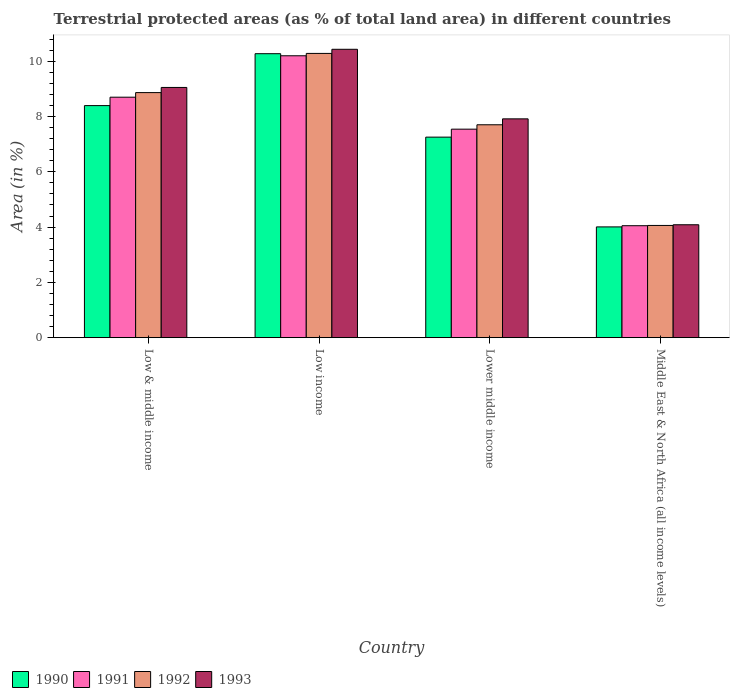Are the number of bars on each tick of the X-axis equal?
Offer a terse response. Yes. In how many cases, is the number of bars for a given country not equal to the number of legend labels?
Give a very brief answer. 0. What is the percentage of terrestrial protected land in 1993 in Lower middle income?
Ensure brevity in your answer.  7.92. Across all countries, what is the maximum percentage of terrestrial protected land in 1993?
Offer a terse response. 10.43. Across all countries, what is the minimum percentage of terrestrial protected land in 1991?
Provide a succinct answer. 4.05. In which country was the percentage of terrestrial protected land in 1992 maximum?
Offer a very short reply. Low income. In which country was the percentage of terrestrial protected land in 1991 minimum?
Make the answer very short. Middle East & North Africa (all income levels). What is the total percentage of terrestrial protected land in 1991 in the graph?
Ensure brevity in your answer.  30.49. What is the difference between the percentage of terrestrial protected land in 1992 in Low & middle income and that in Middle East & North Africa (all income levels)?
Make the answer very short. 4.81. What is the difference between the percentage of terrestrial protected land in 1991 in Low & middle income and the percentage of terrestrial protected land in 1993 in Lower middle income?
Your answer should be compact. 0.78. What is the average percentage of terrestrial protected land in 1993 per country?
Provide a short and direct response. 7.87. What is the difference between the percentage of terrestrial protected land of/in 1993 and percentage of terrestrial protected land of/in 1992 in Low income?
Offer a terse response. 0.15. What is the ratio of the percentage of terrestrial protected land in 1992 in Low income to that in Lower middle income?
Keep it short and to the point. 1.34. Is the percentage of terrestrial protected land in 1991 in Lower middle income less than that in Middle East & North Africa (all income levels)?
Your answer should be very brief. No. What is the difference between the highest and the second highest percentage of terrestrial protected land in 1992?
Give a very brief answer. -1.42. What is the difference between the highest and the lowest percentage of terrestrial protected land in 1993?
Your answer should be compact. 6.35. Is the sum of the percentage of terrestrial protected land in 1991 in Lower middle income and Middle East & North Africa (all income levels) greater than the maximum percentage of terrestrial protected land in 1993 across all countries?
Your answer should be very brief. Yes. What does the 3rd bar from the right in Lower middle income represents?
Your response must be concise. 1991. Is it the case that in every country, the sum of the percentage of terrestrial protected land in 1992 and percentage of terrestrial protected land in 1991 is greater than the percentage of terrestrial protected land in 1993?
Provide a short and direct response. Yes. How many bars are there?
Your answer should be very brief. 16. Are all the bars in the graph horizontal?
Offer a terse response. No. Are the values on the major ticks of Y-axis written in scientific E-notation?
Ensure brevity in your answer.  No. Does the graph contain grids?
Give a very brief answer. No. Where does the legend appear in the graph?
Offer a terse response. Bottom left. How many legend labels are there?
Your answer should be very brief. 4. How are the legend labels stacked?
Offer a very short reply. Horizontal. What is the title of the graph?
Ensure brevity in your answer.  Terrestrial protected areas (as % of total land area) in different countries. What is the label or title of the Y-axis?
Give a very brief answer. Area (in %). What is the Area (in %) in 1990 in Low & middle income?
Your answer should be very brief. 8.4. What is the Area (in %) of 1991 in Low & middle income?
Provide a short and direct response. 8.7. What is the Area (in %) of 1992 in Low & middle income?
Your answer should be compact. 8.87. What is the Area (in %) in 1993 in Low & middle income?
Give a very brief answer. 9.05. What is the Area (in %) in 1990 in Low income?
Your response must be concise. 10.27. What is the Area (in %) in 1991 in Low income?
Your response must be concise. 10.2. What is the Area (in %) in 1992 in Low income?
Your answer should be compact. 10.28. What is the Area (in %) of 1993 in Low income?
Your answer should be very brief. 10.43. What is the Area (in %) in 1990 in Lower middle income?
Ensure brevity in your answer.  7.26. What is the Area (in %) of 1991 in Lower middle income?
Offer a very short reply. 7.54. What is the Area (in %) of 1992 in Lower middle income?
Your answer should be compact. 7.7. What is the Area (in %) of 1993 in Lower middle income?
Offer a terse response. 7.92. What is the Area (in %) in 1990 in Middle East & North Africa (all income levels)?
Provide a short and direct response. 4.01. What is the Area (in %) of 1991 in Middle East & North Africa (all income levels)?
Your answer should be very brief. 4.05. What is the Area (in %) of 1992 in Middle East & North Africa (all income levels)?
Provide a short and direct response. 4.06. What is the Area (in %) in 1993 in Middle East & North Africa (all income levels)?
Your answer should be compact. 4.08. Across all countries, what is the maximum Area (in %) in 1990?
Your answer should be compact. 10.27. Across all countries, what is the maximum Area (in %) of 1991?
Provide a short and direct response. 10.2. Across all countries, what is the maximum Area (in %) of 1992?
Your answer should be very brief. 10.28. Across all countries, what is the maximum Area (in %) of 1993?
Offer a terse response. 10.43. Across all countries, what is the minimum Area (in %) in 1990?
Ensure brevity in your answer.  4.01. Across all countries, what is the minimum Area (in %) in 1991?
Offer a very short reply. 4.05. Across all countries, what is the minimum Area (in %) of 1992?
Your answer should be compact. 4.06. Across all countries, what is the minimum Area (in %) in 1993?
Your answer should be very brief. 4.08. What is the total Area (in %) in 1990 in the graph?
Your answer should be compact. 29.93. What is the total Area (in %) in 1991 in the graph?
Your answer should be very brief. 30.49. What is the total Area (in %) in 1992 in the graph?
Ensure brevity in your answer.  30.91. What is the total Area (in %) of 1993 in the graph?
Make the answer very short. 31.49. What is the difference between the Area (in %) of 1990 in Low & middle income and that in Low income?
Your answer should be very brief. -1.88. What is the difference between the Area (in %) in 1991 in Low & middle income and that in Low income?
Offer a terse response. -1.5. What is the difference between the Area (in %) in 1992 in Low & middle income and that in Low income?
Offer a very short reply. -1.42. What is the difference between the Area (in %) in 1993 in Low & middle income and that in Low income?
Your answer should be compact. -1.38. What is the difference between the Area (in %) of 1990 in Low & middle income and that in Lower middle income?
Your answer should be very brief. 1.14. What is the difference between the Area (in %) in 1991 in Low & middle income and that in Lower middle income?
Keep it short and to the point. 1.16. What is the difference between the Area (in %) of 1992 in Low & middle income and that in Lower middle income?
Give a very brief answer. 1.16. What is the difference between the Area (in %) in 1993 in Low & middle income and that in Lower middle income?
Provide a succinct answer. 1.14. What is the difference between the Area (in %) in 1990 in Low & middle income and that in Middle East & North Africa (all income levels)?
Ensure brevity in your answer.  4.39. What is the difference between the Area (in %) of 1991 in Low & middle income and that in Middle East & North Africa (all income levels)?
Your answer should be compact. 4.65. What is the difference between the Area (in %) in 1992 in Low & middle income and that in Middle East & North Africa (all income levels)?
Offer a very short reply. 4.81. What is the difference between the Area (in %) of 1993 in Low & middle income and that in Middle East & North Africa (all income levels)?
Ensure brevity in your answer.  4.97. What is the difference between the Area (in %) of 1990 in Low income and that in Lower middle income?
Your answer should be very brief. 3.02. What is the difference between the Area (in %) in 1991 in Low income and that in Lower middle income?
Give a very brief answer. 2.65. What is the difference between the Area (in %) in 1992 in Low income and that in Lower middle income?
Give a very brief answer. 2.58. What is the difference between the Area (in %) in 1993 in Low income and that in Lower middle income?
Offer a very short reply. 2.52. What is the difference between the Area (in %) of 1990 in Low income and that in Middle East & North Africa (all income levels)?
Make the answer very short. 6.27. What is the difference between the Area (in %) in 1991 in Low income and that in Middle East & North Africa (all income levels)?
Ensure brevity in your answer.  6.15. What is the difference between the Area (in %) in 1992 in Low income and that in Middle East & North Africa (all income levels)?
Ensure brevity in your answer.  6.22. What is the difference between the Area (in %) of 1993 in Low income and that in Middle East & North Africa (all income levels)?
Make the answer very short. 6.35. What is the difference between the Area (in %) of 1990 in Lower middle income and that in Middle East & North Africa (all income levels)?
Offer a terse response. 3.25. What is the difference between the Area (in %) in 1991 in Lower middle income and that in Middle East & North Africa (all income levels)?
Give a very brief answer. 3.49. What is the difference between the Area (in %) of 1992 in Lower middle income and that in Middle East & North Africa (all income levels)?
Provide a succinct answer. 3.64. What is the difference between the Area (in %) of 1993 in Lower middle income and that in Middle East & North Africa (all income levels)?
Ensure brevity in your answer.  3.83. What is the difference between the Area (in %) of 1990 in Low & middle income and the Area (in %) of 1991 in Low income?
Keep it short and to the point. -1.8. What is the difference between the Area (in %) in 1990 in Low & middle income and the Area (in %) in 1992 in Low income?
Provide a succinct answer. -1.89. What is the difference between the Area (in %) in 1990 in Low & middle income and the Area (in %) in 1993 in Low income?
Offer a very short reply. -2.04. What is the difference between the Area (in %) of 1991 in Low & middle income and the Area (in %) of 1992 in Low income?
Offer a terse response. -1.58. What is the difference between the Area (in %) in 1991 in Low & middle income and the Area (in %) in 1993 in Low income?
Provide a succinct answer. -1.73. What is the difference between the Area (in %) in 1992 in Low & middle income and the Area (in %) in 1993 in Low income?
Ensure brevity in your answer.  -1.57. What is the difference between the Area (in %) of 1990 in Low & middle income and the Area (in %) of 1991 in Lower middle income?
Offer a terse response. 0.85. What is the difference between the Area (in %) in 1990 in Low & middle income and the Area (in %) in 1992 in Lower middle income?
Provide a succinct answer. 0.69. What is the difference between the Area (in %) of 1990 in Low & middle income and the Area (in %) of 1993 in Lower middle income?
Provide a succinct answer. 0.48. What is the difference between the Area (in %) in 1991 in Low & middle income and the Area (in %) in 1993 in Lower middle income?
Provide a short and direct response. 0.78. What is the difference between the Area (in %) of 1992 in Low & middle income and the Area (in %) of 1993 in Lower middle income?
Offer a terse response. 0.95. What is the difference between the Area (in %) of 1990 in Low & middle income and the Area (in %) of 1991 in Middle East & North Africa (all income levels)?
Ensure brevity in your answer.  4.35. What is the difference between the Area (in %) in 1990 in Low & middle income and the Area (in %) in 1992 in Middle East & North Africa (all income levels)?
Your response must be concise. 4.34. What is the difference between the Area (in %) in 1990 in Low & middle income and the Area (in %) in 1993 in Middle East & North Africa (all income levels)?
Make the answer very short. 4.31. What is the difference between the Area (in %) of 1991 in Low & middle income and the Area (in %) of 1992 in Middle East & North Africa (all income levels)?
Give a very brief answer. 4.64. What is the difference between the Area (in %) of 1991 in Low & middle income and the Area (in %) of 1993 in Middle East & North Africa (all income levels)?
Your answer should be very brief. 4.62. What is the difference between the Area (in %) of 1992 in Low & middle income and the Area (in %) of 1993 in Middle East & North Africa (all income levels)?
Offer a terse response. 4.78. What is the difference between the Area (in %) of 1990 in Low income and the Area (in %) of 1991 in Lower middle income?
Keep it short and to the point. 2.73. What is the difference between the Area (in %) of 1990 in Low income and the Area (in %) of 1992 in Lower middle income?
Offer a very short reply. 2.57. What is the difference between the Area (in %) in 1990 in Low income and the Area (in %) in 1993 in Lower middle income?
Your answer should be very brief. 2.36. What is the difference between the Area (in %) in 1991 in Low income and the Area (in %) in 1992 in Lower middle income?
Keep it short and to the point. 2.5. What is the difference between the Area (in %) of 1991 in Low income and the Area (in %) of 1993 in Lower middle income?
Keep it short and to the point. 2.28. What is the difference between the Area (in %) in 1992 in Low income and the Area (in %) in 1993 in Lower middle income?
Make the answer very short. 2.37. What is the difference between the Area (in %) in 1990 in Low income and the Area (in %) in 1991 in Middle East & North Africa (all income levels)?
Make the answer very short. 6.22. What is the difference between the Area (in %) of 1990 in Low income and the Area (in %) of 1992 in Middle East & North Africa (all income levels)?
Ensure brevity in your answer.  6.21. What is the difference between the Area (in %) in 1990 in Low income and the Area (in %) in 1993 in Middle East & North Africa (all income levels)?
Your answer should be very brief. 6.19. What is the difference between the Area (in %) in 1991 in Low income and the Area (in %) in 1992 in Middle East & North Africa (all income levels)?
Offer a terse response. 6.14. What is the difference between the Area (in %) of 1991 in Low income and the Area (in %) of 1993 in Middle East & North Africa (all income levels)?
Offer a terse response. 6.11. What is the difference between the Area (in %) of 1992 in Low income and the Area (in %) of 1993 in Middle East & North Africa (all income levels)?
Your answer should be very brief. 6.2. What is the difference between the Area (in %) of 1990 in Lower middle income and the Area (in %) of 1991 in Middle East & North Africa (all income levels)?
Give a very brief answer. 3.21. What is the difference between the Area (in %) of 1990 in Lower middle income and the Area (in %) of 1992 in Middle East & North Africa (all income levels)?
Keep it short and to the point. 3.2. What is the difference between the Area (in %) of 1990 in Lower middle income and the Area (in %) of 1993 in Middle East & North Africa (all income levels)?
Keep it short and to the point. 3.17. What is the difference between the Area (in %) of 1991 in Lower middle income and the Area (in %) of 1992 in Middle East & North Africa (all income levels)?
Your answer should be very brief. 3.48. What is the difference between the Area (in %) in 1991 in Lower middle income and the Area (in %) in 1993 in Middle East & North Africa (all income levels)?
Offer a very short reply. 3.46. What is the difference between the Area (in %) of 1992 in Lower middle income and the Area (in %) of 1993 in Middle East & North Africa (all income levels)?
Your answer should be compact. 3.62. What is the average Area (in %) in 1990 per country?
Your answer should be compact. 7.48. What is the average Area (in %) of 1991 per country?
Your answer should be compact. 7.62. What is the average Area (in %) in 1992 per country?
Give a very brief answer. 7.73. What is the average Area (in %) of 1993 per country?
Provide a short and direct response. 7.87. What is the difference between the Area (in %) in 1990 and Area (in %) in 1991 in Low & middle income?
Your answer should be compact. -0.3. What is the difference between the Area (in %) in 1990 and Area (in %) in 1992 in Low & middle income?
Your response must be concise. -0.47. What is the difference between the Area (in %) of 1990 and Area (in %) of 1993 in Low & middle income?
Provide a succinct answer. -0.66. What is the difference between the Area (in %) of 1991 and Area (in %) of 1992 in Low & middle income?
Offer a very short reply. -0.17. What is the difference between the Area (in %) of 1991 and Area (in %) of 1993 in Low & middle income?
Make the answer very short. -0.35. What is the difference between the Area (in %) in 1992 and Area (in %) in 1993 in Low & middle income?
Keep it short and to the point. -0.19. What is the difference between the Area (in %) of 1990 and Area (in %) of 1991 in Low income?
Your answer should be compact. 0.08. What is the difference between the Area (in %) in 1990 and Area (in %) in 1992 in Low income?
Keep it short and to the point. -0.01. What is the difference between the Area (in %) in 1990 and Area (in %) in 1993 in Low income?
Offer a very short reply. -0.16. What is the difference between the Area (in %) in 1991 and Area (in %) in 1992 in Low income?
Offer a very short reply. -0.09. What is the difference between the Area (in %) in 1991 and Area (in %) in 1993 in Low income?
Give a very brief answer. -0.23. What is the difference between the Area (in %) of 1992 and Area (in %) of 1993 in Low income?
Keep it short and to the point. -0.15. What is the difference between the Area (in %) in 1990 and Area (in %) in 1991 in Lower middle income?
Your answer should be compact. -0.29. What is the difference between the Area (in %) of 1990 and Area (in %) of 1992 in Lower middle income?
Provide a succinct answer. -0.45. What is the difference between the Area (in %) of 1990 and Area (in %) of 1993 in Lower middle income?
Give a very brief answer. -0.66. What is the difference between the Area (in %) in 1991 and Area (in %) in 1992 in Lower middle income?
Your answer should be very brief. -0.16. What is the difference between the Area (in %) in 1991 and Area (in %) in 1993 in Lower middle income?
Your answer should be compact. -0.37. What is the difference between the Area (in %) of 1992 and Area (in %) of 1993 in Lower middle income?
Give a very brief answer. -0.21. What is the difference between the Area (in %) in 1990 and Area (in %) in 1991 in Middle East & North Africa (all income levels)?
Ensure brevity in your answer.  -0.04. What is the difference between the Area (in %) of 1990 and Area (in %) of 1992 in Middle East & North Africa (all income levels)?
Give a very brief answer. -0.05. What is the difference between the Area (in %) in 1990 and Area (in %) in 1993 in Middle East & North Africa (all income levels)?
Provide a short and direct response. -0.08. What is the difference between the Area (in %) of 1991 and Area (in %) of 1992 in Middle East & North Africa (all income levels)?
Keep it short and to the point. -0.01. What is the difference between the Area (in %) in 1991 and Area (in %) in 1993 in Middle East & North Africa (all income levels)?
Your answer should be compact. -0.03. What is the difference between the Area (in %) of 1992 and Area (in %) of 1993 in Middle East & North Africa (all income levels)?
Your answer should be very brief. -0.02. What is the ratio of the Area (in %) in 1990 in Low & middle income to that in Low income?
Give a very brief answer. 0.82. What is the ratio of the Area (in %) in 1991 in Low & middle income to that in Low income?
Offer a very short reply. 0.85. What is the ratio of the Area (in %) in 1992 in Low & middle income to that in Low income?
Provide a short and direct response. 0.86. What is the ratio of the Area (in %) of 1993 in Low & middle income to that in Low income?
Provide a succinct answer. 0.87. What is the ratio of the Area (in %) of 1990 in Low & middle income to that in Lower middle income?
Give a very brief answer. 1.16. What is the ratio of the Area (in %) of 1991 in Low & middle income to that in Lower middle income?
Keep it short and to the point. 1.15. What is the ratio of the Area (in %) of 1992 in Low & middle income to that in Lower middle income?
Provide a succinct answer. 1.15. What is the ratio of the Area (in %) of 1993 in Low & middle income to that in Lower middle income?
Provide a short and direct response. 1.14. What is the ratio of the Area (in %) in 1990 in Low & middle income to that in Middle East & North Africa (all income levels)?
Make the answer very short. 2.1. What is the ratio of the Area (in %) in 1991 in Low & middle income to that in Middle East & North Africa (all income levels)?
Provide a succinct answer. 2.15. What is the ratio of the Area (in %) of 1992 in Low & middle income to that in Middle East & North Africa (all income levels)?
Ensure brevity in your answer.  2.18. What is the ratio of the Area (in %) in 1993 in Low & middle income to that in Middle East & North Africa (all income levels)?
Keep it short and to the point. 2.22. What is the ratio of the Area (in %) of 1990 in Low income to that in Lower middle income?
Offer a terse response. 1.42. What is the ratio of the Area (in %) of 1991 in Low income to that in Lower middle income?
Keep it short and to the point. 1.35. What is the ratio of the Area (in %) in 1992 in Low income to that in Lower middle income?
Your answer should be compact. 1.34. What is the ratio of the Area (in %) of 1993 in Low income to that in Lower middle income?
Make the answer very short. 1.32. What is the ratio of the Area (in %) of 1990 in Low income to that in Middle East & North Africa (all income levels)?
Offer a terse response. 2.56. What is the ratio of the Area (in %) in 1991 in Low income to that in Middle East & North Africa (all income levels)?
Your response must be concise. 2.52. What is the ratio of the Area (in %) in 1992 in Low income to that in Middle East & North Africa (all income levels)?
Give a very brief answer. 2.53. What is the ratio of the Area (in %) of 1993 in Low income to that in Middle East & North Africa (all income levels)?
Your response must be concise. 2.55. What is the ratio of the Area (in %) in 1990 in Lower middle income to that in Middle East & North Africa (all income levels)?
Offer a terse response. 1.81. What is the ratio of the Area (in %) in 1991 in Lower middle income to that in Middle East & North Africa (all income levels)?
Ensure brevity in your answer.  1.86. What is the ratio of the Area (in %) of 1992 in Lower middle income to that in Middle East & North Africa (all income levels)?
Keep it short and to the point. 1.9. What is the ratio of the Area (in %) of 1993 in Lower middle income to that in Middle East & North Africa (all income levels)?
Give a very brief answer. 1.94. What is the difference between the highest and the second highest Area (in %) in 1990?
Your answer should be compact. 1.88. What is the difference between the highest and the second highest Area (in %) in 1991?
Offer a very short reply. 1.5. What is the difference between the highest and the second highest Area (in %) of 1992?
Make the answer very short. 1.42. What is the difference between the highest and the second highest Area (in %) of 1993?
Make the answer very short. 1.38. What is the difference between the highest and the lowest Area (in %) of 1990?
Your answer should be compact. 6.27. What is the difference between the highest and the lowest Area (in %) in 1991?
Your answer should be very brief. 6.15. What is the difference between the highest and the lowest Area (in %) in 1992?
Ensure brevity in your answer.  6.22. What is the difference between the highest and the lowest Area (in %) in 1993?
Make the answer very short. 6.35. 